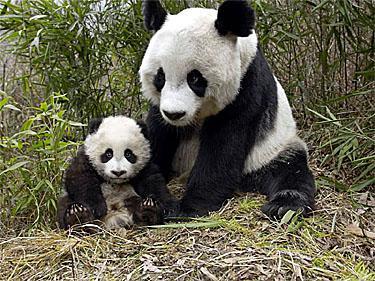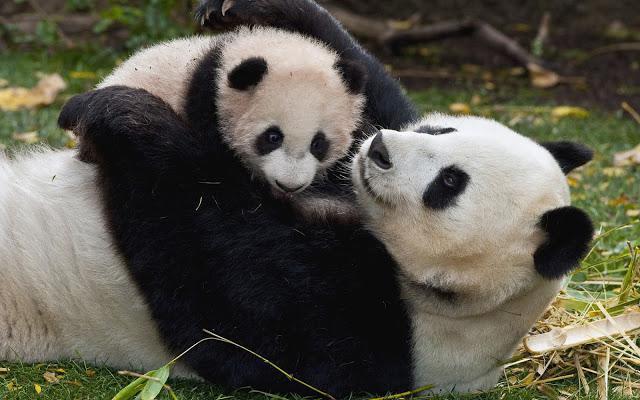The first image is the image on the left, the second image is the image on the right. Evaluate the accuracy of this statement regarding the images: "At least one of the images has a big panda with a much smaller panda.". Is it true? Answer yes or no. Yes. The first image is the image on the left, the second image is the image on the right. Analyze the images presented: Is the assertion "One image has a baby panda being held while on top of an adult panda that is on its back." valid? Answer yes or no. Yes. 